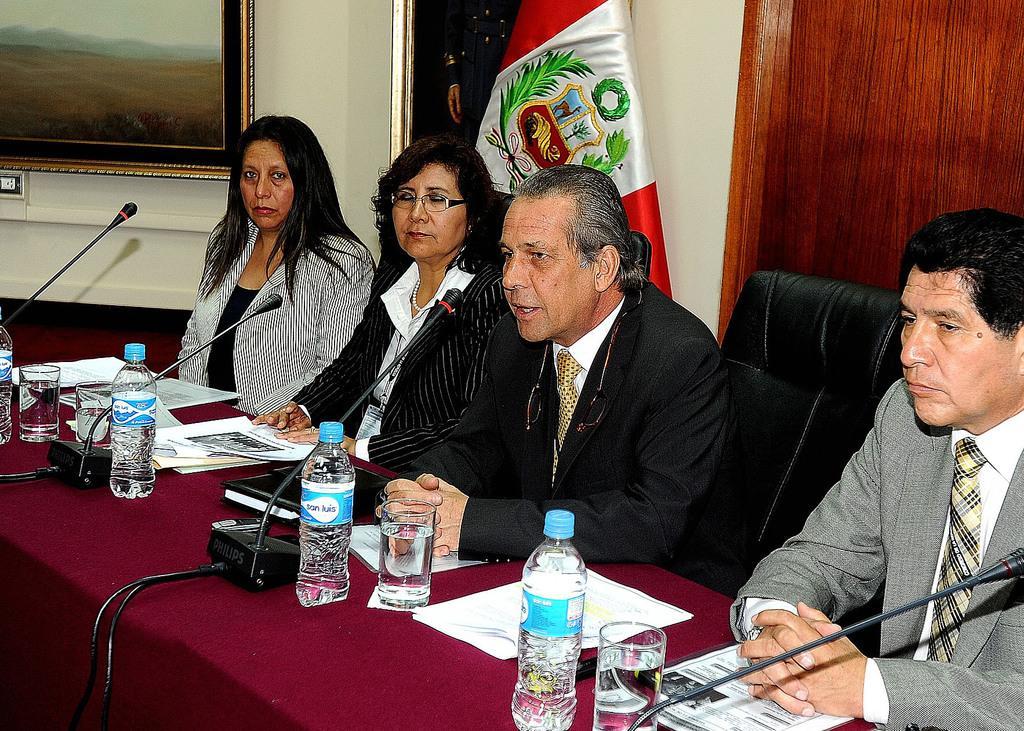Could you give a brief overview of what you see in this image? There are people sitting and speaking in microphone in front of table. 